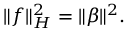Convert formula to latex. <formula><loc_0><loc_0><loc_500><loc_500>\| f \| _ { H } ^ { 2 } = \| \beta \| ^ { 2 } .</formula> 